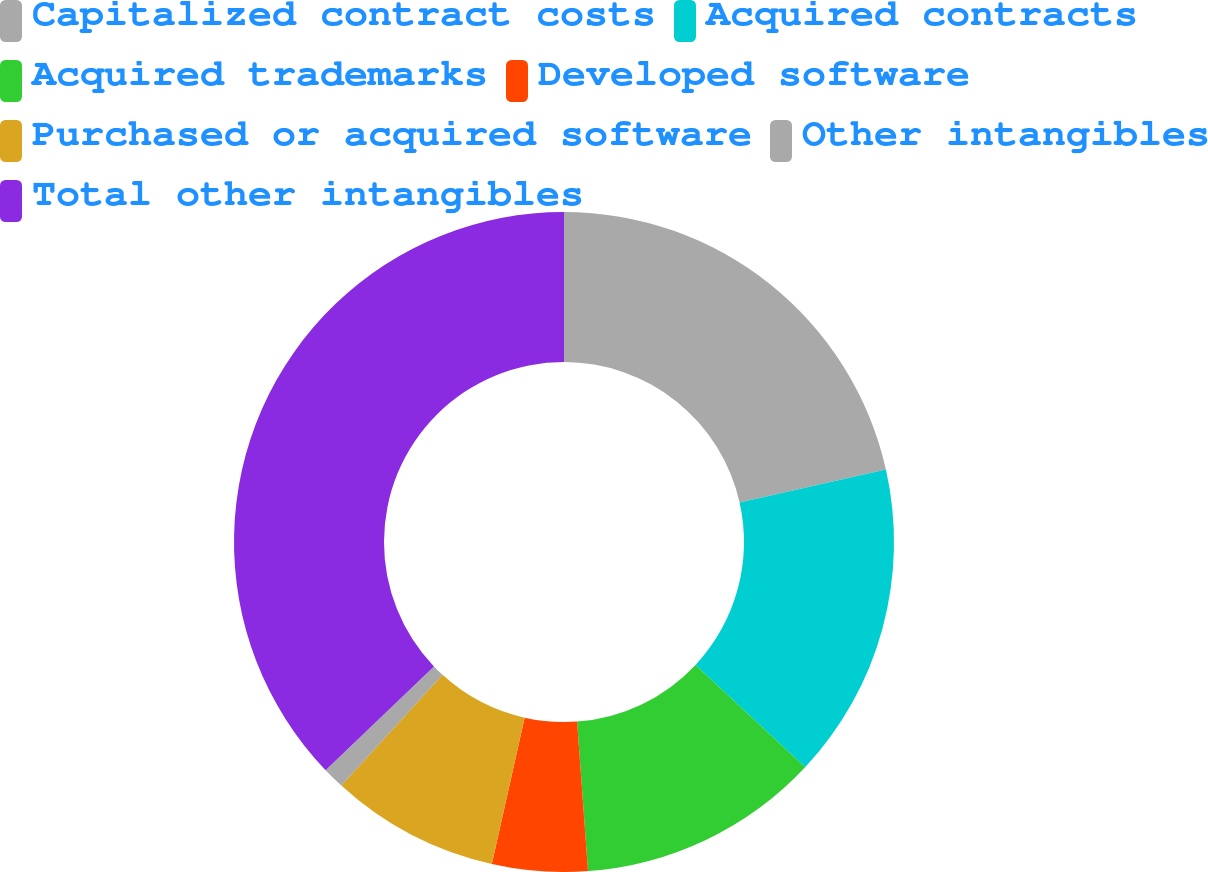<chart> <loc_0><loc_0><loc_500><loc_500><pie_chart><fcel>Capitalized contract costs<fcel>Acquired contracts<fcel>Acquired trademarks<fcel>Developed software<fcel>Purchased or acquired software<fcel>Other intangibles<fcel>Total other intangibles<nl><fcel>21.47%<fcel>15.49%<fcel>11.88%<fcel>4.67%<fcel>8.28%<fcel>1.06%<fcel>37.15%<nl></chart> 